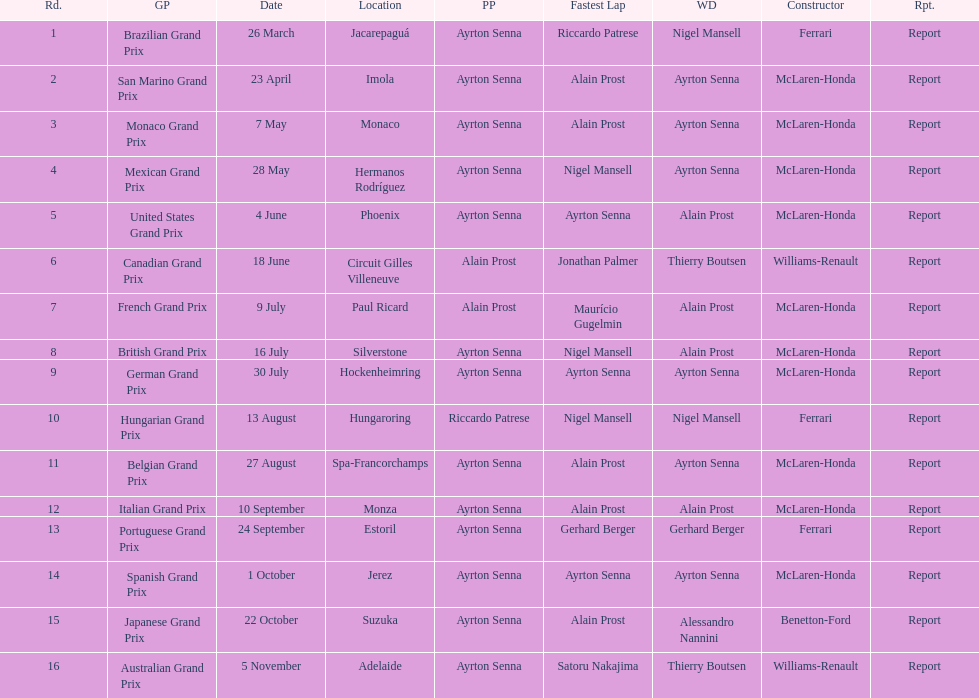Prost won the drivers title, who was his teammate? Ayrton Senna. 